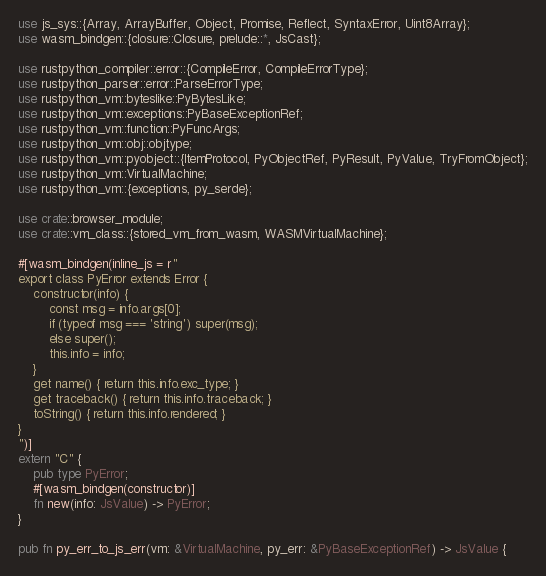Convert code to text. <code><loc_0><loc_0><loc_500><loc_500><_Rust_>use js_sys::{Array, ArrayBuffer, Object, Promise, Reflect, SyntaxError, Uint8Array};
use wasm_bindgen::{closure::Closure, prelude::*, JsCast};

use rustpython_compiler::error::{CompileError, CompileErrorType};
use rustpython_parser::error::ParseErrorType;
use rustpython_vm::byteslike::PyBytesLike;
use rustpython_vm::exceptions::PyBaseExceptionRef;
use rustpython_vm::function::PyFuncArgs;
use rustpython_vm::obj::objtype;
use rustpython_vm::pyobject::{ItemProtocol, PyObjectRef, PyResult, PyValue, TryFromObject};
use rustpython_vm::VirtualMachine;
use rustpython_vm::{exceptions, py_serde};

use crate::browser_module;
use crate::vm_class::{stored_vm_from_wasm, WASMVirtualMachine};

#[wasm_bindgen(inline_js = r"
export class PyError extends Error {
    constructor(info) {
        const msg = info.args[0];
        if (typeof msg === 'string') super(msg);
        else super();
        this.info = info;
    }
    get name() { return this.info.exc_type; }
    get traceback() { return this.info.traceback; }
    toString() { return this.info.rendered; }
}
")]
extern "C" {
    pub type PyError;
    #[wasm_bindgen(constructor)]
    fn new(info: JsValue) -> PyError;
}

pub fn py_err_to_js_err(vm: &VirtualMachine, py_err: &PyBaseExceptionRef) -> JsValue {</code> 